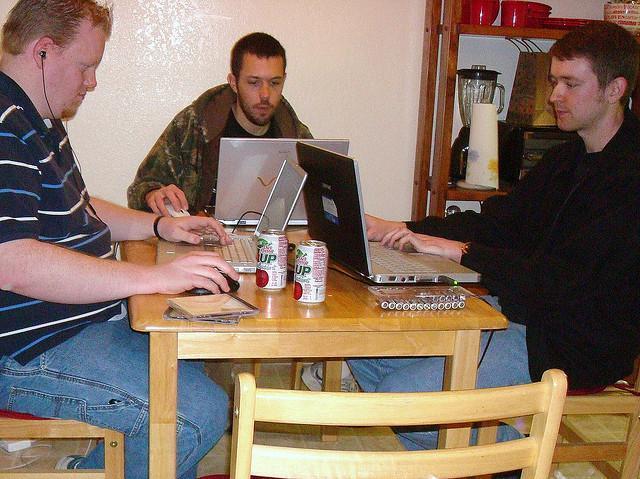How many chairs are around the table?
Give a very brief answer. 4. How many people are visible?
Give a very brief answer. 3. How many laptops are there?
Give a very brief answer. 3. How many chairs are visible?
Give a very brief answer. 3. 